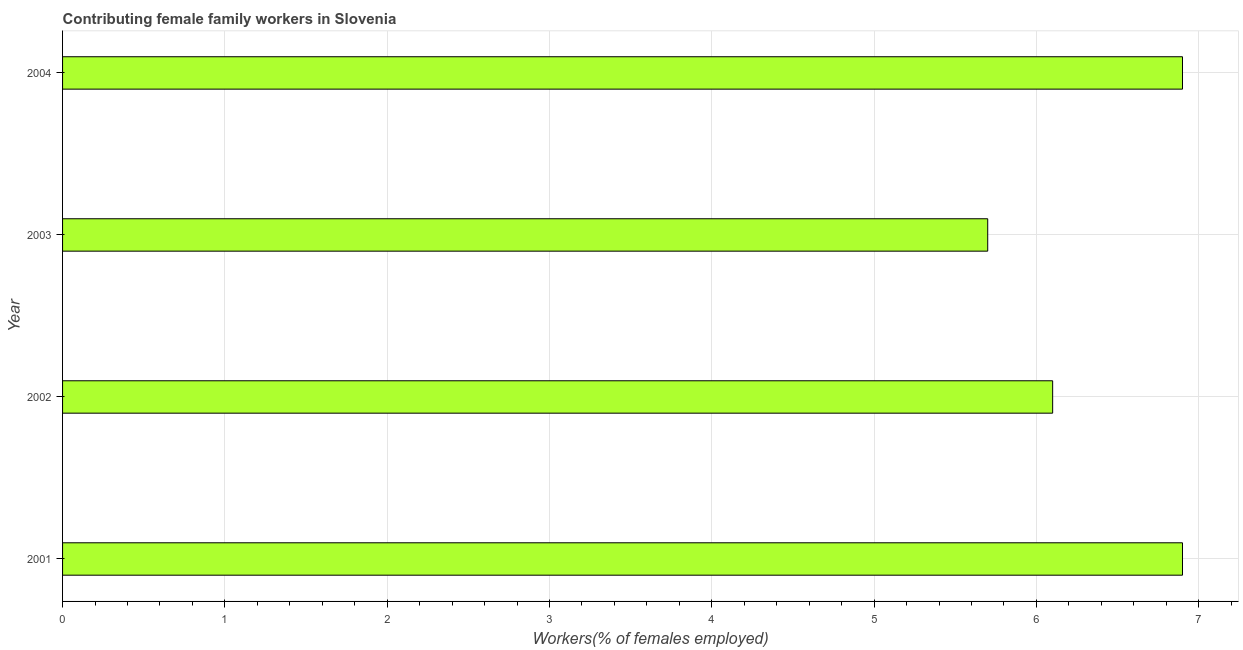Does the graph contain any zero values?
Your answer should be very brief. No. Does the graph contain grids?
Give a very brief answer. Yes. What is the title of the graph?
Provide a short and direct response. Contributing female family workers in Slovenia. What is the label or title of the X-axis?
Your answer should be very brief. Workers(% of females employed). What is the contributing female family workers in 2004?
Keep it short and to the point. 6.9. Across all years, what is the maximum contributing female family workers?
Your response must be concise. 6.9. Across all years, what is the minimum contributing female family workers?
Ensure brevity in your answer.  5.7. In which year was the contributing female family workers maximum?
Your response must be concise. 2001. In which year was the contributing female family workers minimum?
Your answer should be compact. 2003. What is the sum of the contributing female family workers?
Offer a terse response. 25.6. What is the difference between the contributing female family workers in 2002 and 2004?
Provide a short and direct response. -0.8. What is the average contributing female family workers per year?
Provide a succinct answer. 6.4. What is the median contributing female family workers?
Your answer should be compact. 6.5. In how many years, is the contributing female family workers greater than 1.6 %?
Your answer should be compact. 4. What is the ratio of the contributing female family workers in 2002 to that in 2004?
Your answer should be very brief. 0.88. Is the contributing female family workers in 2001 less than that in 2003?
Give a very brief answer. No. Is the sum of the contributing female family workers in 2001 and 2004 greater than the maximum contributing female family workers across all years?
Your answer should be very brief. Yes. In how many years, is the contributing female family workers greater than the average contributing female family workers taken over all years?
Ensure brevity in your answer.  2. Are all the bars in the graph horizontal?
Ensure brevity in your answer.  Yes. What is the Workers(% of females employed) of 2001?
Your answer should be very brief. 6.9. What is the Workers(% of females employed) in 2002?
Keep it short and to the point. 6.1. What is the Workers(% of females employed) of 2003?
Offer a terse response. 5.7. What is the Workers(% of females employed) of 2004?
Keep it short and to the point. 6.9. What is the difference between the Workers(% of females employed) in 2001 and 2002?
Your response must be concise. 0.8. What is the ratio of the Workers(% of females employed) in 2001 to that in 2002?
Provide a short and direct response. 1.13. What is the ratio of the Workers(% of females employed) in 2001 to that in 2003?
Keep it short and to the point. 1.21. What is the ratio of the Workers(% of females employed) in 2002 to that in 2003?
Offer a very short reply. 1.07. What is the ratio of the Workers(% of females employed) in 2002 to that in 2004?
Offer a terse response. 0.88. What is the ratio of the Workers(% of females employed) in 2003 to that in 2004?
Your response must be concise. 0.83. 